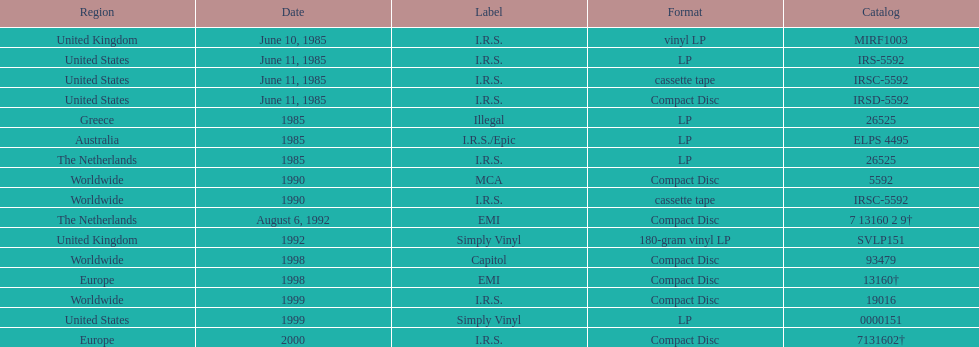What is the maximum successive quantity of releases in lp format? 3. 